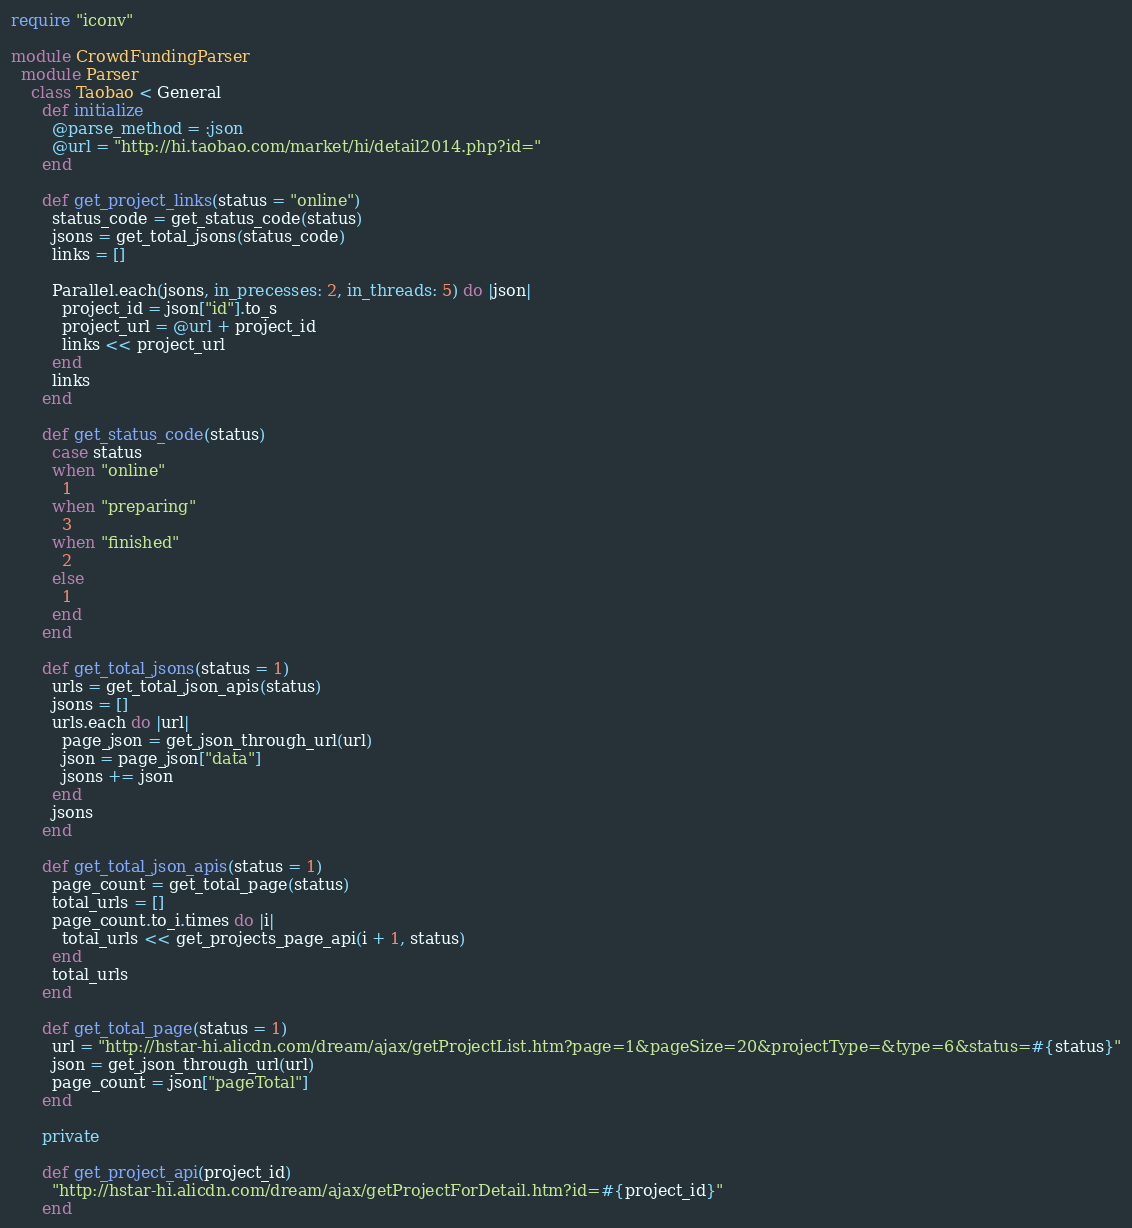Convert code to text. <code><loc_0><loc_0><loc_500><loc_500><_Ruby_>require "iconv"

module CrowdFundingParser
  module Parser
    class Taobao < General
      def initialize
        @parse_method = :json
        @url = "http://hi.taobao.com/market/hi/detail2014.php?id="
      end

      def get_project_links(status = "online")
        status_code = get_status_code(status)
        jsons = get_total_jsons(status_code)
        links = []

        Parallel.each(jsons, in_precesses: 2, in_threads: 5) do |json|
          project_id = json["id"].to_s
          project_url = @url + project_id
          links << project_url
        end
        links
      end

      def get_status_code(status)
        case status
        when "online"
          1
        when "preparing"
          3
        when "finished"
          2
        else
          1
        end
      end

      def get_total_jsons(status = 1)
        urls = get_total_json_apis(status)
        jsons = []
        urls.each do |url|
          page_json = get_json_through_url(url)
          json = page_json["data"]
          jsons += json
        end
        jsons
      end

      def get_total_json_apis(status = 1)
        page_count = get_total_page(status)
        total_urls = []
        page_count.to_i.times do |i|
          total_urls << get_projects_page_api(i + 1, status)
        end
        total_urls
      end

      def get_total_page(status = 1)
        url = "http://hstar-hi.alicdn.com/dream/ajax/getProjectList.htm?page=1&pageSize=20&projectType=&type=6&status=#{status}"
        json = get_json_through_url(url)
        page_count = json["pageTotal"]
      end

      private

      def get_project_api(project_id)
        "http://hstar-hi.alicdn.com/dream/ajax/getProjectForDetail.htm?id=#{project_id}"
      end
</code> 